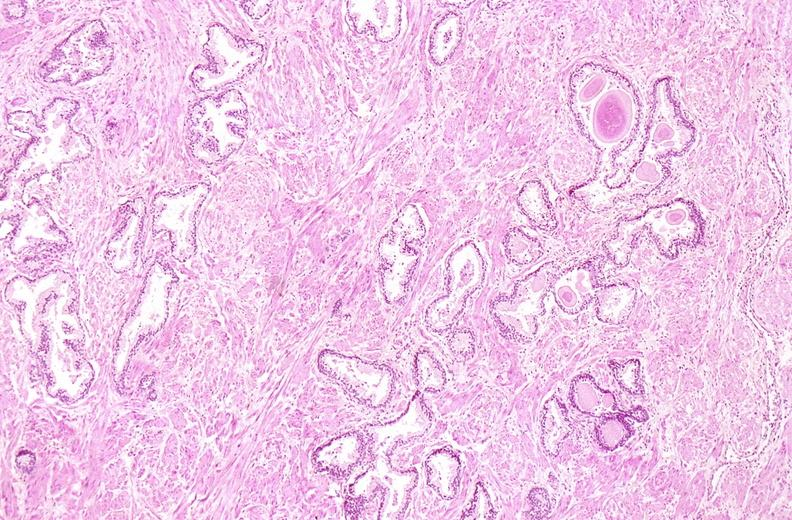what does this image show?
Answer the question using a single word or phrase. Prostate 